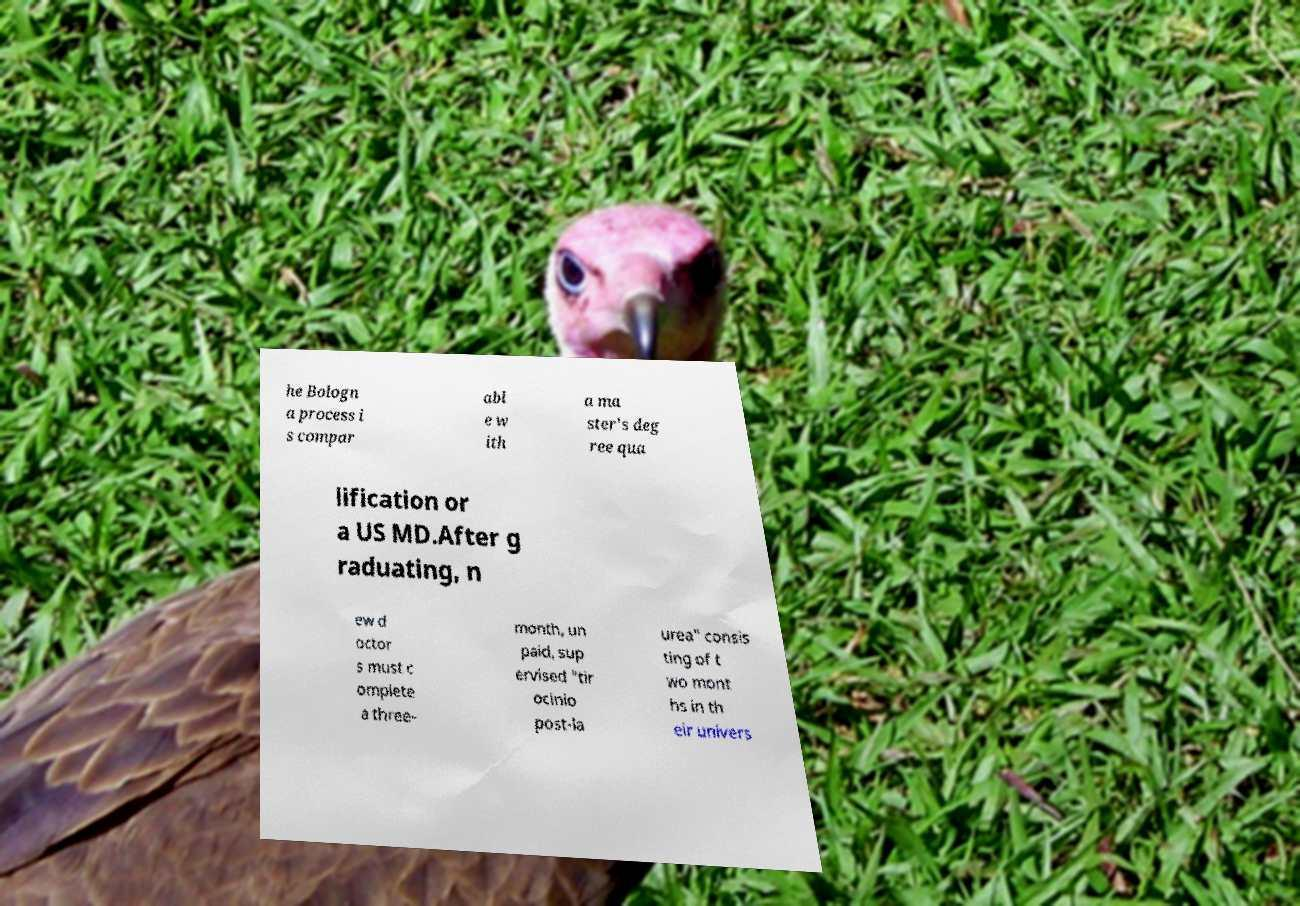Please read and relay the text visible in this image. What does it say? he Bologn a process i s compar abl e w ith a ma ster's deg ree qua lification or a US MD.After g raduating, n ew d octor s must c omplete a three- month, un paid, sup ervised "tir ocinio post-la urea" consis ting of t wo mont hs in th eir univers 